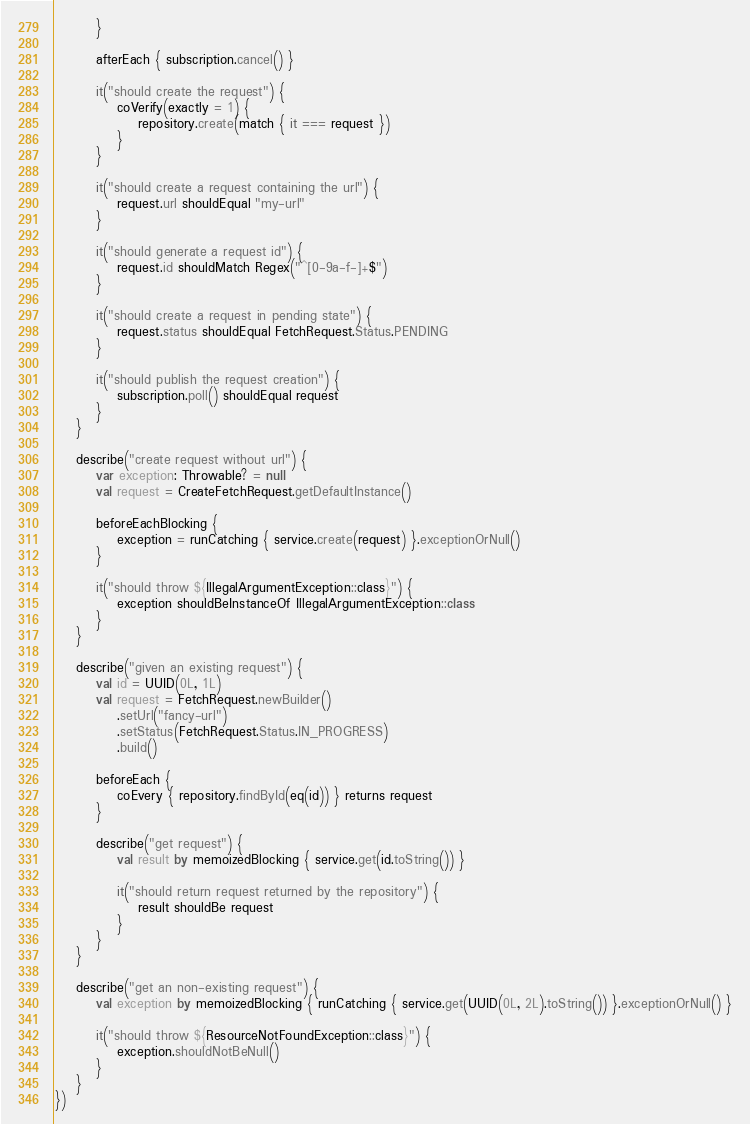Convert code to text. <code><loc_0><loc_0><loc_500><loc_500><_Kotlin_>        }

        afterEach { subscription.cancel() }

        it("should create the request") {
            coVerify(exactly = 1) {
                repository.create(match { it === request })
            }
        }

        it("should create a request containing the url") {
            request.url shouldEqual "my-url"
        }

        it("should generate a request id") {
            request.id shouldMatch Regex("^[0-9a-f-]+$")
        }

        it("should create a request in pending state") {
            request.status shouldEqual FetchRequest.Status.PENDING
        }

        it("should publish the request creation") {
            subscription.poll() shouldEqual request
        }
    }

    describe("create request without url") {
        var exception: Throwable? = null
        val request = CreateFetchRequest.getDefaultInstance()

        beforeEachBlocking {
            exception = runCatching { service.create(request) }.exceptionOrNull()
        }

        it("should throw ${IllegalArgumentException::class}") {
            exception shouldBeInstanceOf IllegalArgumentException::class
        }
    }

    describe("given an existing request") {
        val id = UUID(0L, 1L)
        val request = FetchRequest.newBuilder()
            .setUrl("fancy-url")
            .setStatus(FetchRequest.Status.IN_PROGRESS)
            .build()

        beforeEach {
            coEvery { repository.findById(eq(id)) } returns request
        }

        describe("get request") {
            val result by memoizedBlocking { service.get(id.toString()) }

            it("should return request returned by the repository") {
                result shouldBe request
            }
        }
    }

    describe("get an non-existing request") {
        val exception by memoizedBlocking { runCatching { service.get(UUID(0L, 2L).toString()) }.exceptionOrNull() }

        it("should throw ${ResourceNotFoundException::class}") {
            exception.shouldNotBeNull()
        }
    }
})
</code> 